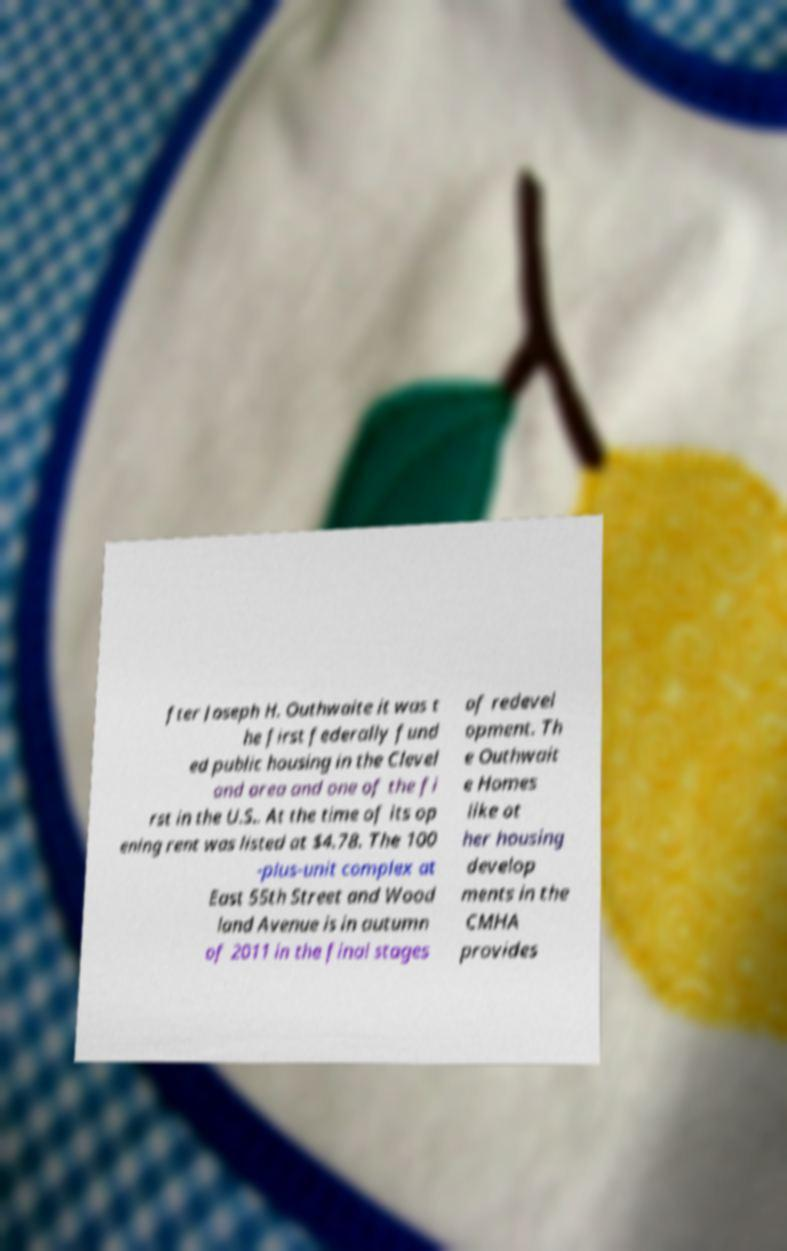Could you assist in decoding the text presented in this image and type it out clearly? fter Joseph H. Outhwaite it was t he first federally fund ed public housing in the Clevel and area and one of the fi rst in the U.S.. At the time of its op ening rent was listed at $4.78. The 100 -plus-unit complex at East 55th Street and Wood land Avenue is in autumn of 2011 in the final stages of redevel opment. Th e Outhwait e Homes like ot her housing develop ments in the CMHA provides 